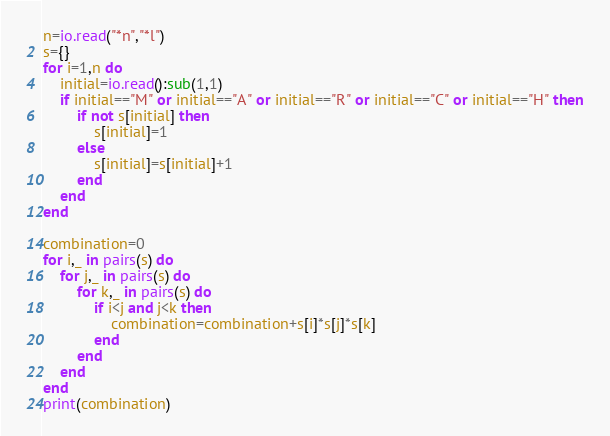<code> <loc_0><loc_0><loc_500><loc_500><_Lua_>n=io.read("*n","*l")
s={}
for i=1,n do
    initial=io.read():sub(1,1)
    if initial=="M" or initial=="A" or initial=="R" or initial=="C" or initial=="H" then
        if not s[initial] then
            s[initial]=1
        else
            s[initial]=s[initial]+1
        end
    end
end

combination=0
for i,_ in pairs(s) do
    for j,_ in pairs(s) do
        for k,_ in pairs(s) do
            if i<j and j<k then
                combination=combination+s[i]*s[j]*s[k]
            end
        end
    end
end
print(combination)</code> 